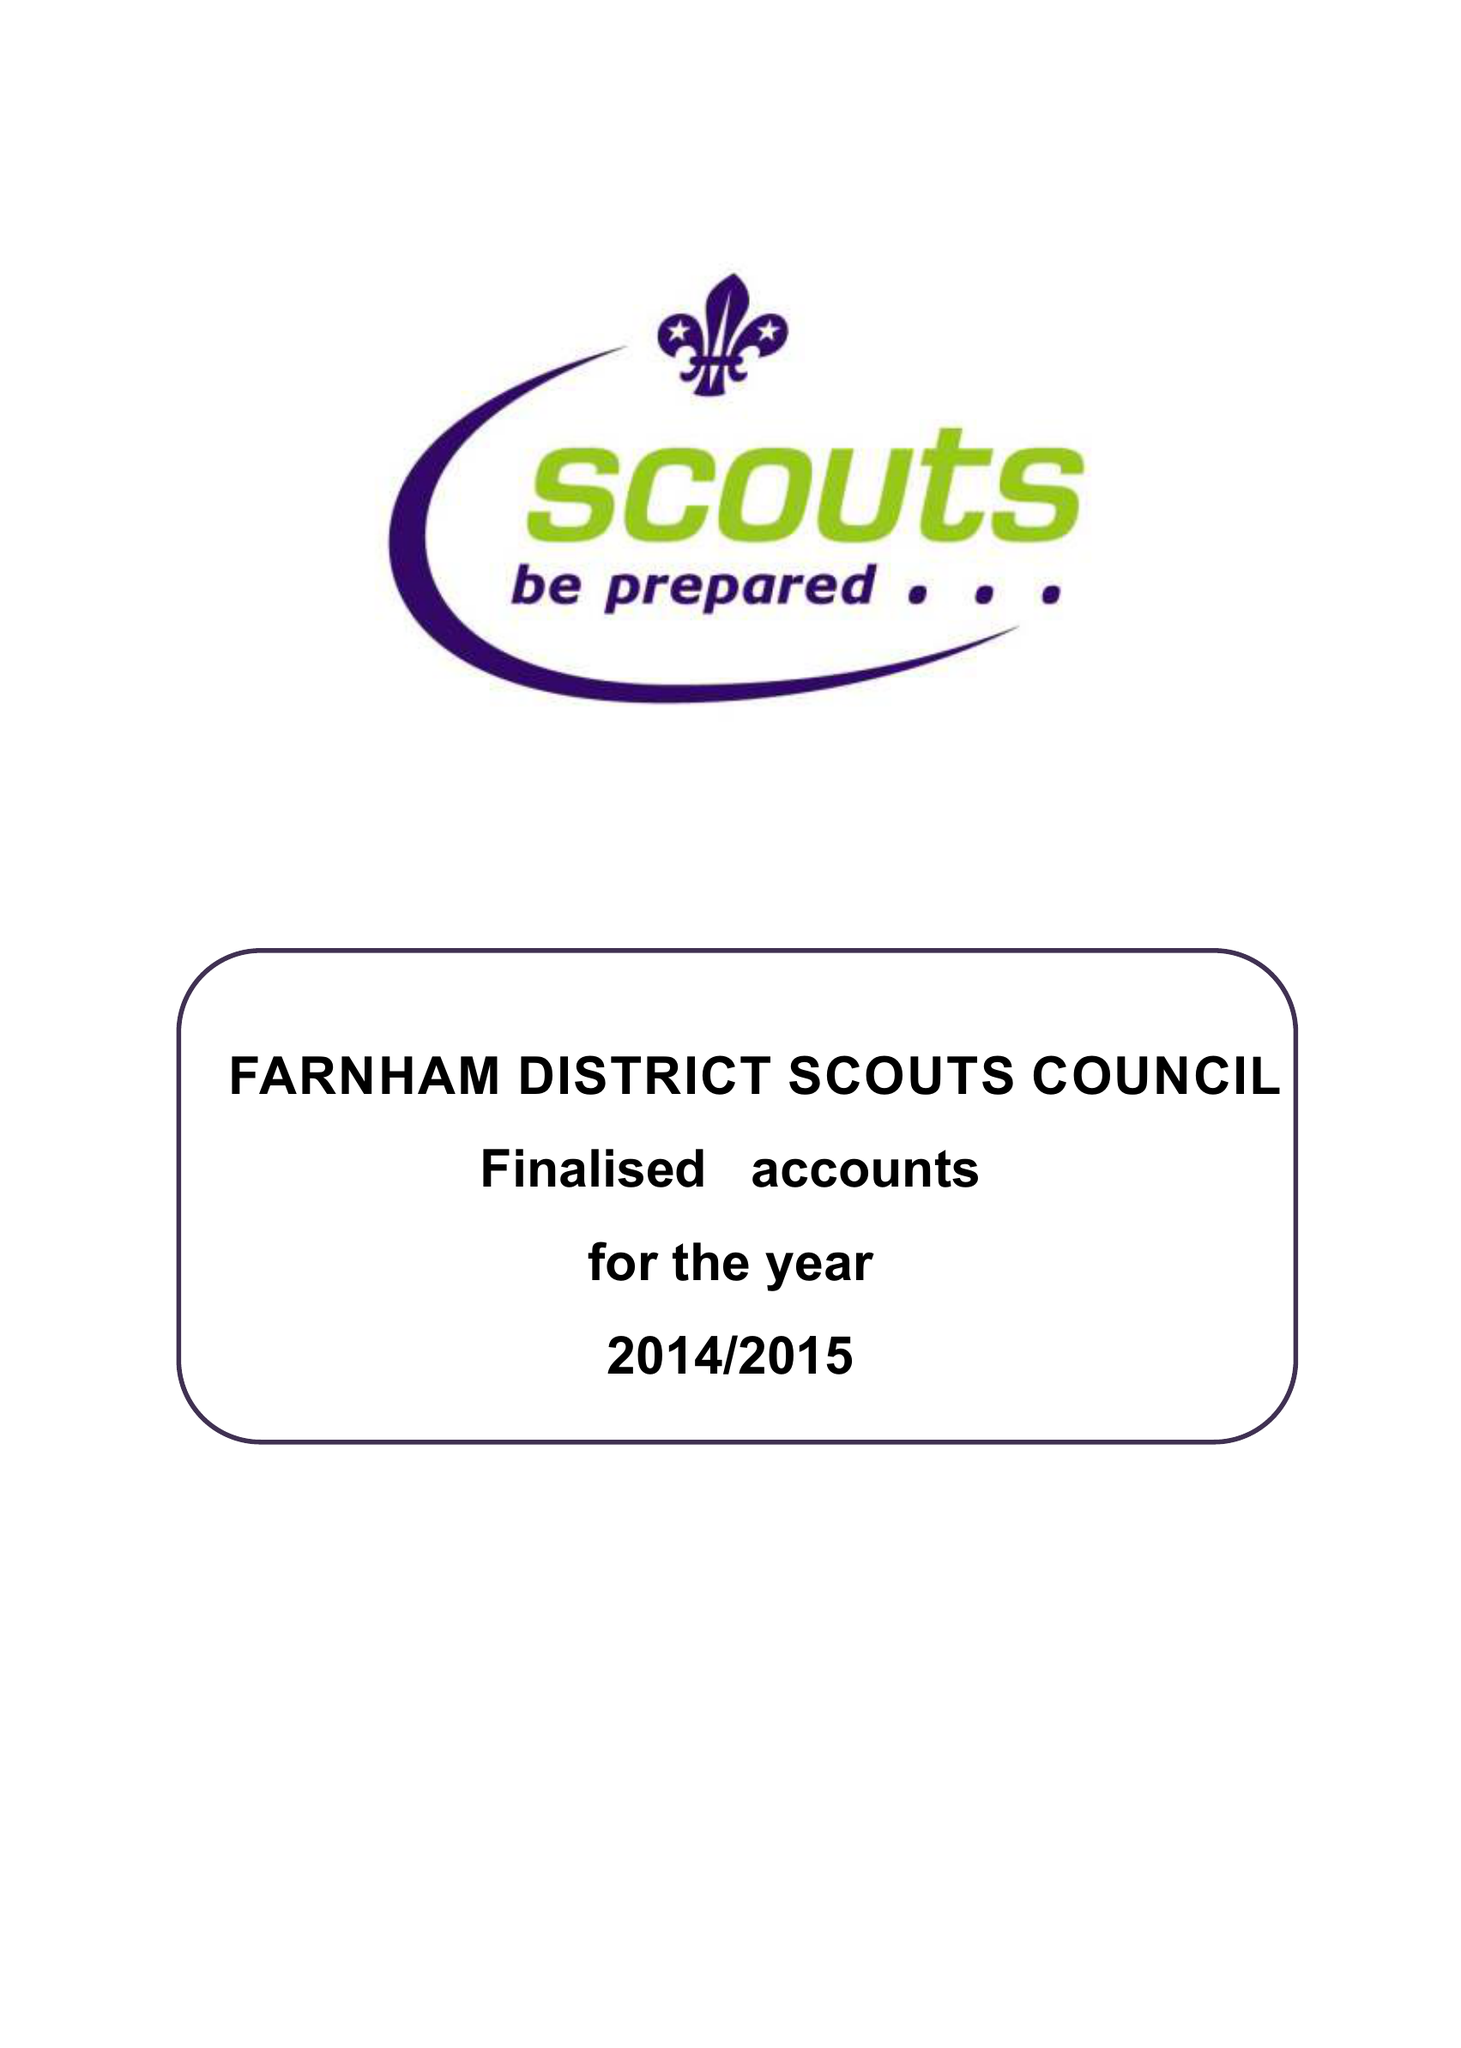What is the value for the address__street_line?
Answer the question using a single word or phrase. 1 YOLLAND CLOSE 